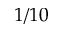Convert formula to latex. <formula><loc_0><loc_0><loc_500><loc_500>1 / 1 0</formula> 